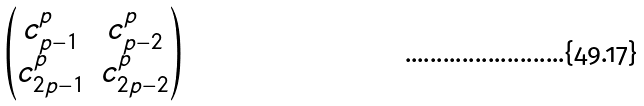<formula> <loc_0><loc_0><loc_500><loc_500>\begin{pmatrix} c _ { p - 1 } ^ { p } & c _ { p - 2 } ^ { p } \\ c _ { 2 p - 1 } ^ { p } & c _ { 2 p - 2 } ^ { p } \end{pmatrix}</formula> 